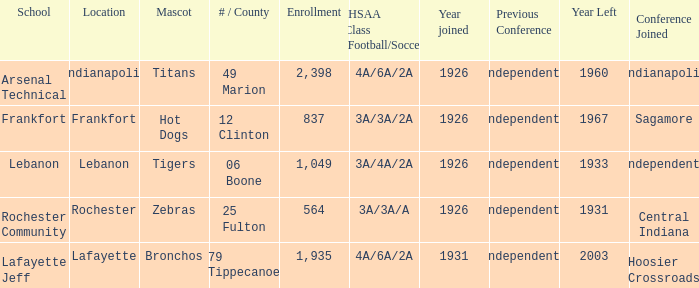What is the typical enrollment featuring hot dogs as the mascot, and a year joined after 1926? None. 